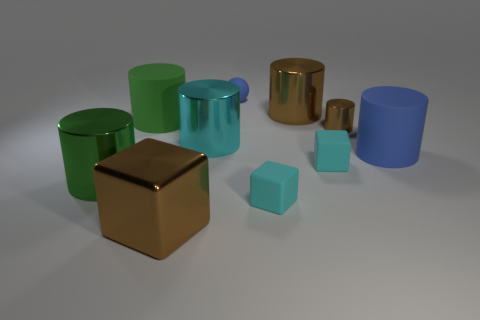Are any big cyan spheres visible?
Offer a very short reply. No. There is a cube that is the same color as the small cylinder; what is it made of?
Keep it short and to the point. Metal. What number of rubber things have the same color as the ball?
Offer a terse response. 1. What number of things are either large things behind the blue cylinder or blue objects in front of the big cyan metallic thing?
Keep it short and to the point. 4. There is a shiny cylinder behind the green matte cylinder; what number of blue rubber spheres are to the left of it?
Your response must be concise. 1. The block that is the same material as the tiny brown cylinder is what color?
Offer a terse response. Brown. Is there a blue metallic cube that has the same size as the brown cube?
Provide a succinct answer. No. Are there any other cyan objects that have the same shape as the small metal thing?
Keep it short and to the point. Yes. Is the material of the cyan cylinder the same as the cyan block in front of the big green metal cylinder?
Your answer should be compact. No. Are there any matte cubes of the same color as the large metal cube?
Ensure brevity in your answer.  No. 